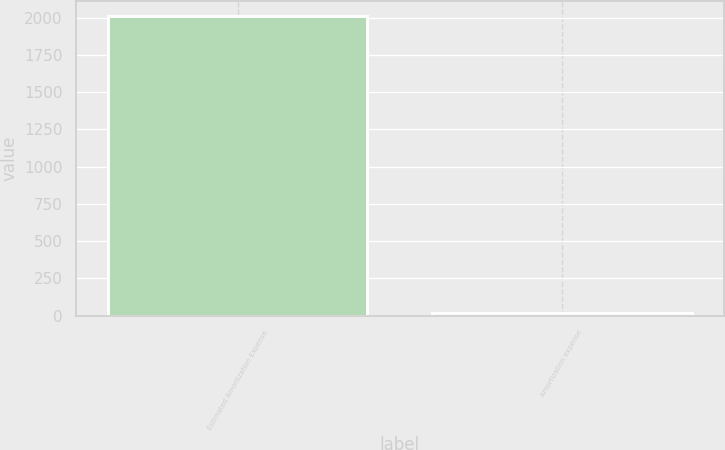Convert chart. <chart><loc_0><loc_0><loc_500><loc_500><bar_chart><fcel>Estimated Amortization Expense<fcel>Amortization expense<nl><fcel>2013<fcel>19<nl></chart> 